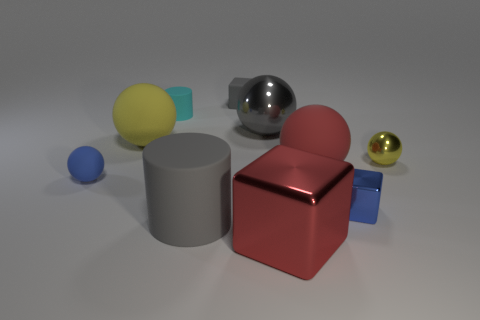Subtract all cyan blocks. How many yellow balls are left? 2 Subtract all small blue blocks. How many blocks are left? 2 Subtract 1 blocks. How many blocks are left? 2 Subtract all yellow spheres. How many spheres are left? 3 Subtract all blocks. How many objects are left? 7 Subtract all cyan balls. Subtract all gray cylinders. How many balls are left? 5 Subtract all tiny gray blocks. Subtract all small things. How many objects are left? 4 Add 7 small yellow things. How many small yellow things are left? 8 Add 7 gray things. How many gray things exist? 10 Subtract 0 red cylinders. How many objects are left? 10 